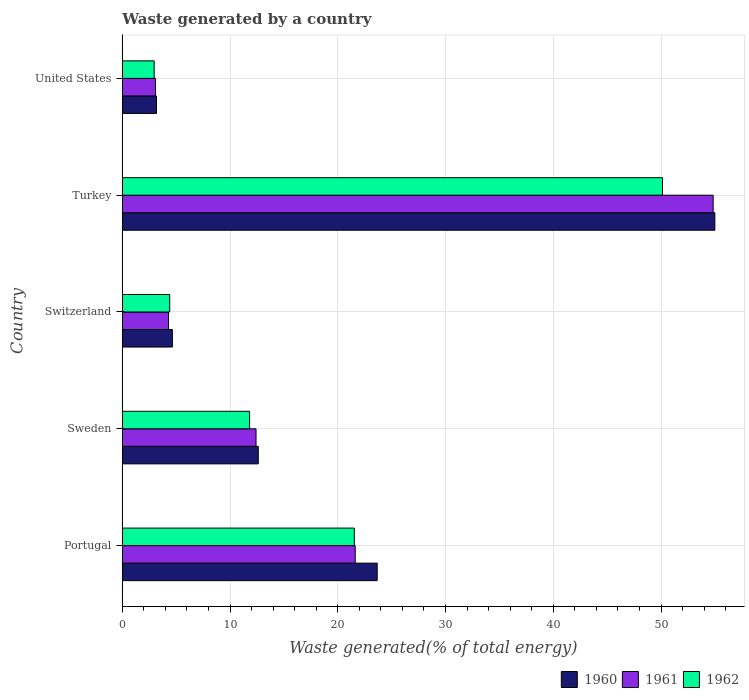Are the number of bars per tick equal to the number of legend labels?
Your answer should be very brief. Yes. How many bars are there on the 3rd tick from the top?
Ensure brevity in your answer.  3. How many bars are there on the 1st tick from the bottom?
Provide a short and direct response. 3. In how many cases, is the number of bars for a given country not equal to the number of legend labels?
Give a very brief answer. 0. What is the total waste generated in 1960 in Portugal?
Your answer should be compact. 23.66. Across all countries, what is the maximum total waste generated in 1961?
Provide a short and direct response. 54.84. Across all countries, what is the minimum total waste generated in 1960?
Ensure brevity in your answer.  3.17. In which country was the total waste generated in 1960 minimum?
Provide a succinct answer. United States. What is the total total waste generated in 1960 in the graph?
Keep it short and to the point. 99.1. What is the difference between the total waste generated in 1960 in Sweden and that in Switzerland?
Make the answer very short. 7.97. What is the difference between the total waste generated in 1961 in United States and the total waste generated in 1962 in Switzerland?
Provide a short and direct response. -1.32. What is the average total waste generated in 1962 per country?
Keep it short and to the point. 18.17. What is the difference between the total waste generated in 1961 and total waste generated in 1960 in Switzerland?
Offer a very short reply. -0.36. In how many countries, is the total waste generated in 1961 greater than 46 %?
Your response must be concise. 1. What is the ratio of the total waste generated in 1962 in Portugal to that in Sweden?
Keep it short and to the point. 1.82. Is the total waste generated in 1961 in Sweden less than that in United States?
Give a very brief answer. No. What is the difference between the highest and the second highest total waste generated in 1961?
Make the answer very short. 33.22. What is the difference between the highest and the lowest total waste generated in 1961?
Provide a succinct answer. 51.76. Is the sum of the total waste generated in 1962 in Turkey and United States greater than the maximum total waste generated in 1961 across all countries?
Keep it short and to the point. No. What does the 3rd bar from the top in Sweden represents?
Offer a very short reply. 1960. What does the 3rd bar from the bottom in Sweden represents?
Your answer should be very brief. 1962. Is it the case that in every country, the sum of the total waste generated in 1962 and total waste generated in 1961 is greater than the total waste generated in 1960?
Make the answer very short. Yes. How many bars are there?
Your answer should be compact. 15. Are all the bars in the graph horizontal?
Ensure brevity in your answer.  Yes. What is the difference between two consecutive major ticks on the X-axis?
Keep it short and to the point. 10. Are the values on the major ticks of X-axis written in scientific E-notation?
Ensure brevity in your answer.  No. How many legend labels are there?
Offer a very short reply. 3. What is the title of the graph?
Your answer should be very brief. Waste generated by a country. Does "1966" appear as one of the legend labels in the graph?
Keep it short and to the point. No. What is the label or title of the X-axis?
Ensure brevity in your answer.  Waste generated(% of total energy). What is the label or title of the Y-axis?
Ensure brevity in your answer.  Country. What is the Waste generated(% of total energy) of 1960 in Portugal?
Your answer should be compact. 23.66. What is the Waste generated(% of total energy) in 1961 in Portugal?
Provide a short and direct response. 21.62. What is the Waste generated(% of total energy) in 1962 in Portugal?
Make the answer very short. 21.53. What is the Waste generated(% of total energy) in 1960 in Sweden?
Your response must be concise. 12.62. What is the Waste generated(% of total energy) in 1961 in Sweden?
Keep it short and to the point. 12.41. What is the Waste generated(% of total energy) in 1962 in Sweden?
Your answer should be compact. 11.82. What is the Waste generated(% of total energy) of 1960 in Switzerland?
Your answer should be very brief. 4.65. What is the Waste generated(% of total energy) of 1961 in Switzerland?
Offer a terse response. 4.29. What is the Waste generated(% of total energy) of 1962 in Switzerland?
Keep it short and to the point. 4.4. What is the Waste generated(% of total energy) in 1960 in Turkey?
Offer a terse response. 54.99. What is the Waste generated(% of total energy) of 1961 in Turkey?
Ensure brevity in your answer.  54.84. What is the Waste generated(% of total energy) of 1962 in Turkey?
Offer a very short reply. 50.13. What is the Waste generated(% of total energy) of 1960 in United States?
Your answer should be very brief. 3.17. What is the Waste generated(% of total energy) in 1961 in United States?
Provide a succinct answer. 3.08. What is the Waste generated(% of total energy) of 1962 in United States?
Your response must be concise. 2.96. Across all countries, what is the maximum Waste generated(% of total energy) in 1960?
Provide a short and direct response. 54.99. Across all countries, what is the maximum Waste generated(% of total energy) in 1961?
Your answer should be very brief. 54.84. Across all countries, what is the maximum Waste generated(% of total energy) of 1962?
Your answer should be compact. 50.13. Across all countries, what is the minimum Waste generated(% of total energy) of 1960?
Make the answer very short. 3.17. Across all countries, what is the minimum Waste generated(% of total energy) in 1961?
Provide a short and direct response. 3.08. Across all countries, what is the minimum Waste generated(% of total energy) of 1962?
Give a very brief answer. 2.96. What is the total Waste generated(% of total energy) of 1960 in the graph?
Make the answer very short. 99.1. What is the total Waste generated(% of total energy) in 1961 in the graph?
Give a very brief answer. 96.24. What is the total Waste generated(% of total energy) in 1962 in the graph?
Offer a terse response. 90.85. What is the difference between the Waste generated(% of total energy) in 1960 in Portugal and that in Sweden?
Give a very brief answer. 11.03. What is the difference between the Waste generated(% of total energy) in 1961 in Portugal and that in Sweden?
Provide a short and direct response. 9.2. What is the difference between the Waste generated(% of total energy) of 1962 in Portugal and that in Sweden?
Ensure brevity in your answer.  9.72. What is the difference between the Waste generated(% of total energy) in 1960 in Portugal and that in Switzerland?
Keep it short and to the point. 19.01. What is the difference between the Waste generated(% of total energy) of 1961 in Portugal and that in Switzerland?
Offer a very short reply. 17.32. What is the difference between the Waste generated(% of total energy) of 1962 in Portugal and that in Switzerland?
Ensure brevity in your answer.  17.13. What is the difference between the Waste generated(% of total energy) in 1960 in Portugal and that in Turkey?
Your response must be concise. -31.34. What is the difference between the Waste generated(% of total energy) in 1961 in Portugal and that in Turkey?
Provide a succinct answer. -33.22. What is the difference between the Waste generated(% of total energy) in 1962 in Portugal and that in Turkey?
Offer a very short reply. -28.6. What is the difference between the Waste generated(% of total energy) of 1960 in Portugal and that in United States?
Offer a very short reply. 20.48. What is the difference between the Waste generated(% of total energy) in 1961 in Portugal and that in United States?
Make the answer very short. 18.54. What is the difference between the Waste generated(% of total energy) of 1962 in Portugal and that in United States?
Your response must be concise. 18.57. What is the difference between the Waste generated(% of total energy) in 1960 in Sweden and that in Switzerland?
Your answer should be very brief. 7.97. What is the difference between the Waste generated(% of total energy) in 1961 in Sweden and that in Switzerland?
Make the answer very short. 8.12. What is the difference between the Waste generated(% of total energy) of 1962 in Sweden and that in Switzerland?
Give a very brief answer. 7.41. What is the difference between the Waste generated(% of total energy) in 1960 in Sweden and that in Turkey?
Provide a short and direct response. -42.37. What is the difference between the Waste generated(% of total energy) in 1961 in Sweden and that in Turkey?
Your response must be concise. -42.43. What is the difference between the Waste generated(% of total energy) in 1962 in Sweden and that in Turkey?
Offer a very short reply. -38.32. What is the difference between the Waste generated(% of total energy) of 1960 in Sweden and that in United States?
Ensure brevity in your answer.  9.45. What is the difference between the Waste generated(% of total energy) of 1961 in Sweden and that in United States?
Provide a short and direct response. 9.33. What is the difference between the Waste generated(% of total energy) in 1962 in Sweden and that in United States?
Ensure brevity in your answer.  8.86. What is the difference between the Waste generated(% of total energy) in 1960 in Switzerland and that in Turkey?
Give a very brief answer. -50.34. What is the difference between the Waste generated(% of total energy) in 1961 in Switzerland and that in Turkey?
Make the answer very short. -50.55. What is the difference between the Waste generated(% of total energy) in 1962 in Switzerland and that in Turkey?
Provide a short and direct response. -45.73. What is the difference between the Waste generated(% of total energy) in 1960 in Switzerland and that in United States?
Ensure brevity in your answer.  1.48. What is the difference between the Waste generated(% of total energy) in 1961 in Switzerland and that in United States?
Offer a terse response. 1.21. What is the difference between the Waste generated(% of total energy) of 1962 in Switzerland and that in United States?
Your answer should be very brief. 1.44. What is the difference between the Waste generated(% of total energy) of 1960 in Turkey and that in United States?
Your answer should be very brief. 51.82. What is the difference between the Waste generated(% of total energy) in 1961 in Turkey and that in United States?
Your answer should be very brief. 51.76. What is the difference between the Waste generated(% of total energy) in 1962 in Turkey and that in United States?
Provide a short and direct response. 47.17. What is the difference between the Waste generated(% of total energy) in 1960 in Portugal and the Waste generated(% of total energy) in 1961 in Sweden?
Your answer should be compact. 11.24. What is the difference between the Waste generated(% of total energy) of 1960 in Portugal and the Waste generated(% of total energy) of 1962 in Sweden?
Make the answer very short. 11.84. What is the difference between the Waste generated(% of total energy) in 1961 in Portugal and the Waste generated(% of total energy) in 1962 in Sweden?
Your response must be concise. 9.8. What is the difference between the Waste generated(% of total energy) in 1960 in Portugal and the Waste generated(% of total energy) in 1961 in Switzerland?
Offer a terse response. 19.36. What is the difference between the Waste generated(% of total energy) of 1960 in Portugal and the Waste generated(% of total energy) of 1962 in Switzerland?
Ensure brevity in your answer.  19.25. What is the difference between the Waste generated(% of total energy) in 1961 in Portugal and the Waste generated(% of total energy) in 1962 in Switzerland?
Make the answer very short. 17.21. What is the difference between the Waste generated(% of total energy) in 1960 in Portugal and the Waste generated(% of total energy) in 1961 in Turkey?
Give a very brief answer. -31.18. What is the difference between the Waste generated(% of total energy) of 1960 in Portugal and the Waste generated(% of total energy) of 1962 in Turkey?
Offer a very short reply. -26.48. What is the difference between the Waste generated(% of total energy) of 1961 in Portugal and the Waste generated(% of total energy) of 1962 in Turkey?
Make the answer very short. -28.52. What is the difference between the Waste generated(% of total energy) of 1960 in Portugal and the Waste generated(% of total energy) of 1961 in United States?
Your response must be concise. 20.58. What is the difference between the Waste generated(% of total energy) in 1960 in Portugal and the Waste generated(% of total energy) in 1962 in United States?
Make the answer very short. 20.7. What is the difference between the Waste generated(% of total energy) of 1961 in Portugal and the Waste generated(% of total energy) of 1962 in United States?
Keep it short and to the point. 18.66. What is the difference between the Waste generated(% of total energy) in 1960 in Sweden and the Waste generated(% of total energy) in 1961 in Switzerland?
Make the answer very short. 8.33. What is the difference between the Waste generated(% of total energy) of 1960 in Sweden and the Waste generated(% of total energy) of 1962 in Switzerland?
Your answer should be compact. 8.22. What is the difference between the Waste generated(% of total energy) in 1961 in Sweden and the Waste generated(% of total energy) in 1962 in Switzerland?
Give a very brief answer. 8.01. What is the difference between the Waste generated(% of total energy) of 1960 in Sweden and the Waste generated(% of total energy) of 1961 in Turkey?
Ensure brevity in your answer.  -42.22. What is the difference between the Waste generated(% of total energy) in 1960 in Sweden and the Waste generated(% of total energy) in 1962 in Turkey?
Provide a short and direct response. -37.51. What is the difference between the Waste generated(% of total energy) of 1961 in Sweden and the Waste generated(% of total energy) of 1962 in Turkey?
Make the answer very short. -37.72. What is the difference between the Waste generated(% of total energy) of 1960 in Sweden and the Waste generated(% of total energy) of 1961 in United States?
Keep it short and to the point. 9.54. What is the difference between the Waste generated(% of total energy) of 1960 in Sweden and the Waste generated(% of total energy) of 1962 in United States?
Offer a very short reply. 9.66. What is the difference between the Waste generated(% of total energy) of 1961 in Sweden and the Waste generated(% of total energy) of 1962 in United States?
Your answer should be very brief. 9.45. What is the difference between the Waste generated(% of total energy) of 1960 in Switzerland and the Waste generated(% of total energy) of 1961 in Turkey?
Provide a short and direct response. -50.19. What is the difference between the Waste generated(% of total energy) of 1960 in Switzerland and the Waste generated(% of total energy) of 1962 in Turkey?
Your response must be concise. -45.48. What is the difference between the Waste generated(% of total energy) in 1961 in Switzerland and the Waste generated(% of total energy) in 1962 in Turkey?
Make the answer very short. -45.84. What is the difference between the Waste generated(% of total energy) in 1960 in Switzerland and the Waste generated(% of total energy) in 1961 in United States?
Your answer should be compact. 1.57. What is the difference between the Waste generated(% of total energy) of 1960 in Switzerland and the Waste generated(% of total energy) of 1962 in United States?
Keep it short and to the point. 1.69. What is the difference between the Waste generated(% of total energy) in 1961 in Switzerland and the Waste generated(% of total energy) in 1962 in United States?
Ensure brevity in your answer.  1.33. What is the difference between the Waste generated(% of total energy) of 1960 in Turkey and the Waste generated(% of total energy) of 1961 in United States?
Offer a terse response. 51.92. What is the difference between the Waste generated(% of total energy) of 1960 in Turkey and the Waste generated(% of total energy) of 1962 in United States?
Provide a succinct answer. 52.03. What is the difference between the Waste generated(% of total energy) of 1961 in Turkey and the Waste generated(% of total energy) of 1962 in United States?
Offer a terse response. 51.88. What is the average Waste generated(% of total energy) in 1960 per country?
Provide a short and direct response. 19.82. What is the average Waste generated(% of total energy) of 1961 per country?
Provide a succinct answer. 19.25. What is the average Waste generated(% of total energy) in 1962 per country?
Give a very brief answer. 18.17. What is the difference between the Waste generated(% of total energy) in 1960 and Waste generated(% of total energy) in 1961 in Portugal?
Your answer should be compact. 2.04. What is the difference between the Waste generated(% of total energy) of 1960 and Waste generated(% of total energy) of 1962 in Portugal?
Provide a succinct answer. 2.12. What is the difference between the Waste generated(% of total energy) of 1961 and Waste generated(% of total energy) of 1962 in Portugal?
Offer a terse response. 0.08. What is the difference between the Waste generated(% of total energy) of 1960 and Waste generated(% of total energy) of 1961 in Sweden?
Provide a short and direct response. 0.21. What is the difference between the Waste generated(% of total energy) in 1960 and Waste generated(% of total energy) in 1962 in Sweden?
Give a very brief answer. 0.81. What is the difference between the Waste generated(% of total energy) of 1961 and Waste generated(% of total energy) of 1962 in Sweden?
Offer a terse response. 0.6. What is the difference between the Waste generated(% of total energy) in 1960 and Waste generated(% of total energy) in 1961 in Switzerland?
Ensure brevity in your answer.  0.36. What is the difference between the Waste generated(% of total energy) of 1960 and Waste generated(% of total energy) of 1962 in Switzerland?
Ensure brevity in your answer.  0.25. What is the difference between the Waste generated(% of total energy) of 1961 and Waste generated(% of total energy) of 1962 in Switzerland?
Offer a terse response. -0.11. What is the difference between the Waste generated(% of total energy) in 1960 and Waste generated(% of total energy) in 1961 in Turkey?
Offer a terse response. 0.16. What is the difference between the Waste generated(% of total energy) of 1960 and Waste generated(% of total energy) of 1962 in Turkey?
Keep it short and to the point. 4.86. What is the difference between the Waste generated(% of total energy) of 1961 and Waste generated(% of total energy) of 1962 in Turkey?
Provide a short and direct response. 4.7. What is the difference between the Waste generated(% of total energy) in 1960 and Waste generated(% of total energy) in 1961 in United States?
Your answer should be very brief. 0.1. What is the difference between the Waste generated(% of total energy) in 1960 and Waste generated(% of total energy) in 1962 in United States?
Keep it short and to the point. 0.21. What is the difference between the Waste generated(% of total energy) in 1961 and Waste generated(% of total energy) in 1962 in United States?
Your answer should be compact. 0.12. What is the ratio of the Waste generated(% of total energy) in 1960 in Portugal to that in Sweden?
Make the answer very short. 1.87. What is the ratio of the Waste generated(% of total energy) in 1961 in Portugal to that in Sweden?
Offer a very short reply. 1.74. What is the ratio of the Waste generated(% of total energy) in 1962 in Portugal to that in Sweden?
Give a very brief answer. 1.82. What is the ratio of the Waste generated(% of total energy) of 1960 in Portugal to that in Switzerland?
Give a very brief answer. 5.09. What is the ratio of the Waste generated(% of total energy) in 1961 in Portugal to that in Switzerland?
Give a very brief answer. 5.04. What is the ratio of the Waste generated(% of total energy) of 1962 in Portugal to that in Switzerland?
Offer a very short reply. 4.89. What is the ratio of the Waste generated(% of total energy) of 1960 in Portugal to that in Turkey?
Keep it short and to the point. 0.43. What is the ratio of the Waste generated(% of total energy) in 1961 in Portugal to that in Turkey?
Your answer should be compact. 0.39. What is the ratio of the Waste generated(% of total energy) in 1962 in Portugal to that in Turkey?
Provide a short and direct response. 0.43. What is the ratio of the Waste generated(% of total energy) in 1960 in Portugal to that in United States?
Your answer should be compact. 7.45. What is the ratio of the Waste generated(% of total energy) of 1961 in Portugal to that in United States?
Provide a short and direct response. 7.02. What is the ratio of the Waste generated(% of total energy) in 1962 in Portugal to that in United States?
Give a very brief answer. 7.27. What is the ratio of the Waste generated(% of total energy) in 1960 in Sweden to that in Switzerland?
Offer a terse response. 2.71. What is the ratio of the Waste generated(% of total energy) in 1961 in Sweden to that in Switzerland?
Make the answer very short. 2.89. What is the ratio of the Waste generated(% of total energy) in 1962 in Sweden to that in Switzerland?
Keep it short and to the point. 2.68. What is the ratio of the Waste generated(% of total energy) in 1960 in Sweden to that in Turkey?
Provide a succinct answer. 0.23. What is the ratio of the Waste generated(% of total energy) of 1961 in Sweden to that in Turkey?
Offer a terse response. 0.23. What is the ratio of the Waste generated(% of total energy) of 1962 in Sweden to that in Turkey?
Your answer should be very brief. 0.24. What is the ratio of the Waste generated(% of total energy) of 1960 in Sweden to that in United States?
Your answer should be very brief. 3.98. What is the ratio of the Waste generated(% of total energy) in 1961 in Sweden to that in United States?
Make the answer very short. 4.03. What is the ratio of the Waste generated(% of total energy) in 1962 in Sweden to that in United States?
Provide a succinct answer. 3.99. What is the ratio of the Waste generated(% of total energy) of 1960 in Switzerland to that in Turkey?
Your response must be concise. 0.08. What is the ratio of the Waste generated(% of total energy) in 1961 in Switzerland to that in Turkey?
Offer a very short reply. 0.08. What is the ratio of the Waste generated(% of total energy) in 1962 in Switzerland to that in Turkey?
Provide a short and direct response. 0.09. What is the ratio of the Waste generated(% of total energy) of 1960 in Switzerland to that in United States?
Provide a succinct answer. 1.46. What is the ratio of the Waste generated(% of total energy) in 1961 in Switzerland to that in United States?
Offer a terse response. 1.39. What is the ratio of the Waste generated(% of total energy) in 1962 in Switzerland to that in United States?
Your answer should be very brief. 1.49. What is the ratio of the Waste generated(% of total energy) in 1960 in Turkey to that in United States?
Offer a terse response. 17.32. What is the ratio of the Waste generated(% of total energy) of 1961 in Turkey to that in United States?
Ensure brevity in your answer.  17.81. What is the ratio of the Waste generated(% of total energy) in 1962 in Turkey to that in United States?
Offer a terse response. 16.94. What is the difference between the highest and the second highest Waste generated(% of total energy) in 1960?
Offer a terse response. 31.34. What is the difference between the highest and the second highest Waste generated(% of total energy) of 1961?
Your answer should be very brief. 33.22. What is the difference between the highest and the second highest Waste generated(% of total energy) in 1962?
Give a very brief answer. 28.6. What is the difference between the highest and the lowest Waste generated(% of total energy) in 1960?
Make the answer very short. 51.82. What is the difference between the highest and the lowest Waste generated(% of total energy) of 1961?
Your answer should be compact. 51.76. What is the difference between the highest and the lowest Waste generated(% of total energy) in 1962?
Give a very brief answer. 47.17. 